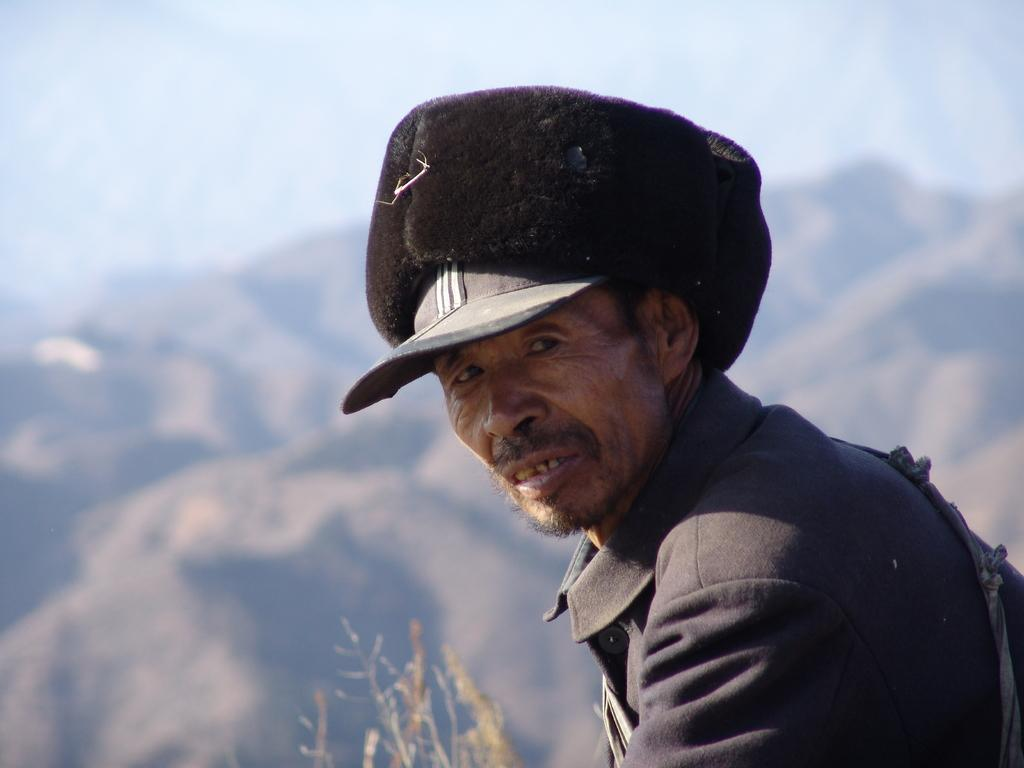Who or what is present in the image? There is a person in the image. What is the person wearing on their head? The person is wearing a cap. What can be seen at the bottom of the image? There are objects at the bottom of the image. What type of landscape can be seen in the background of the image? Hills and the sky are visible in the background of the image. How does the cow show respect in the image? There is no cow present in the image, and therefore, it cannot show respect. 